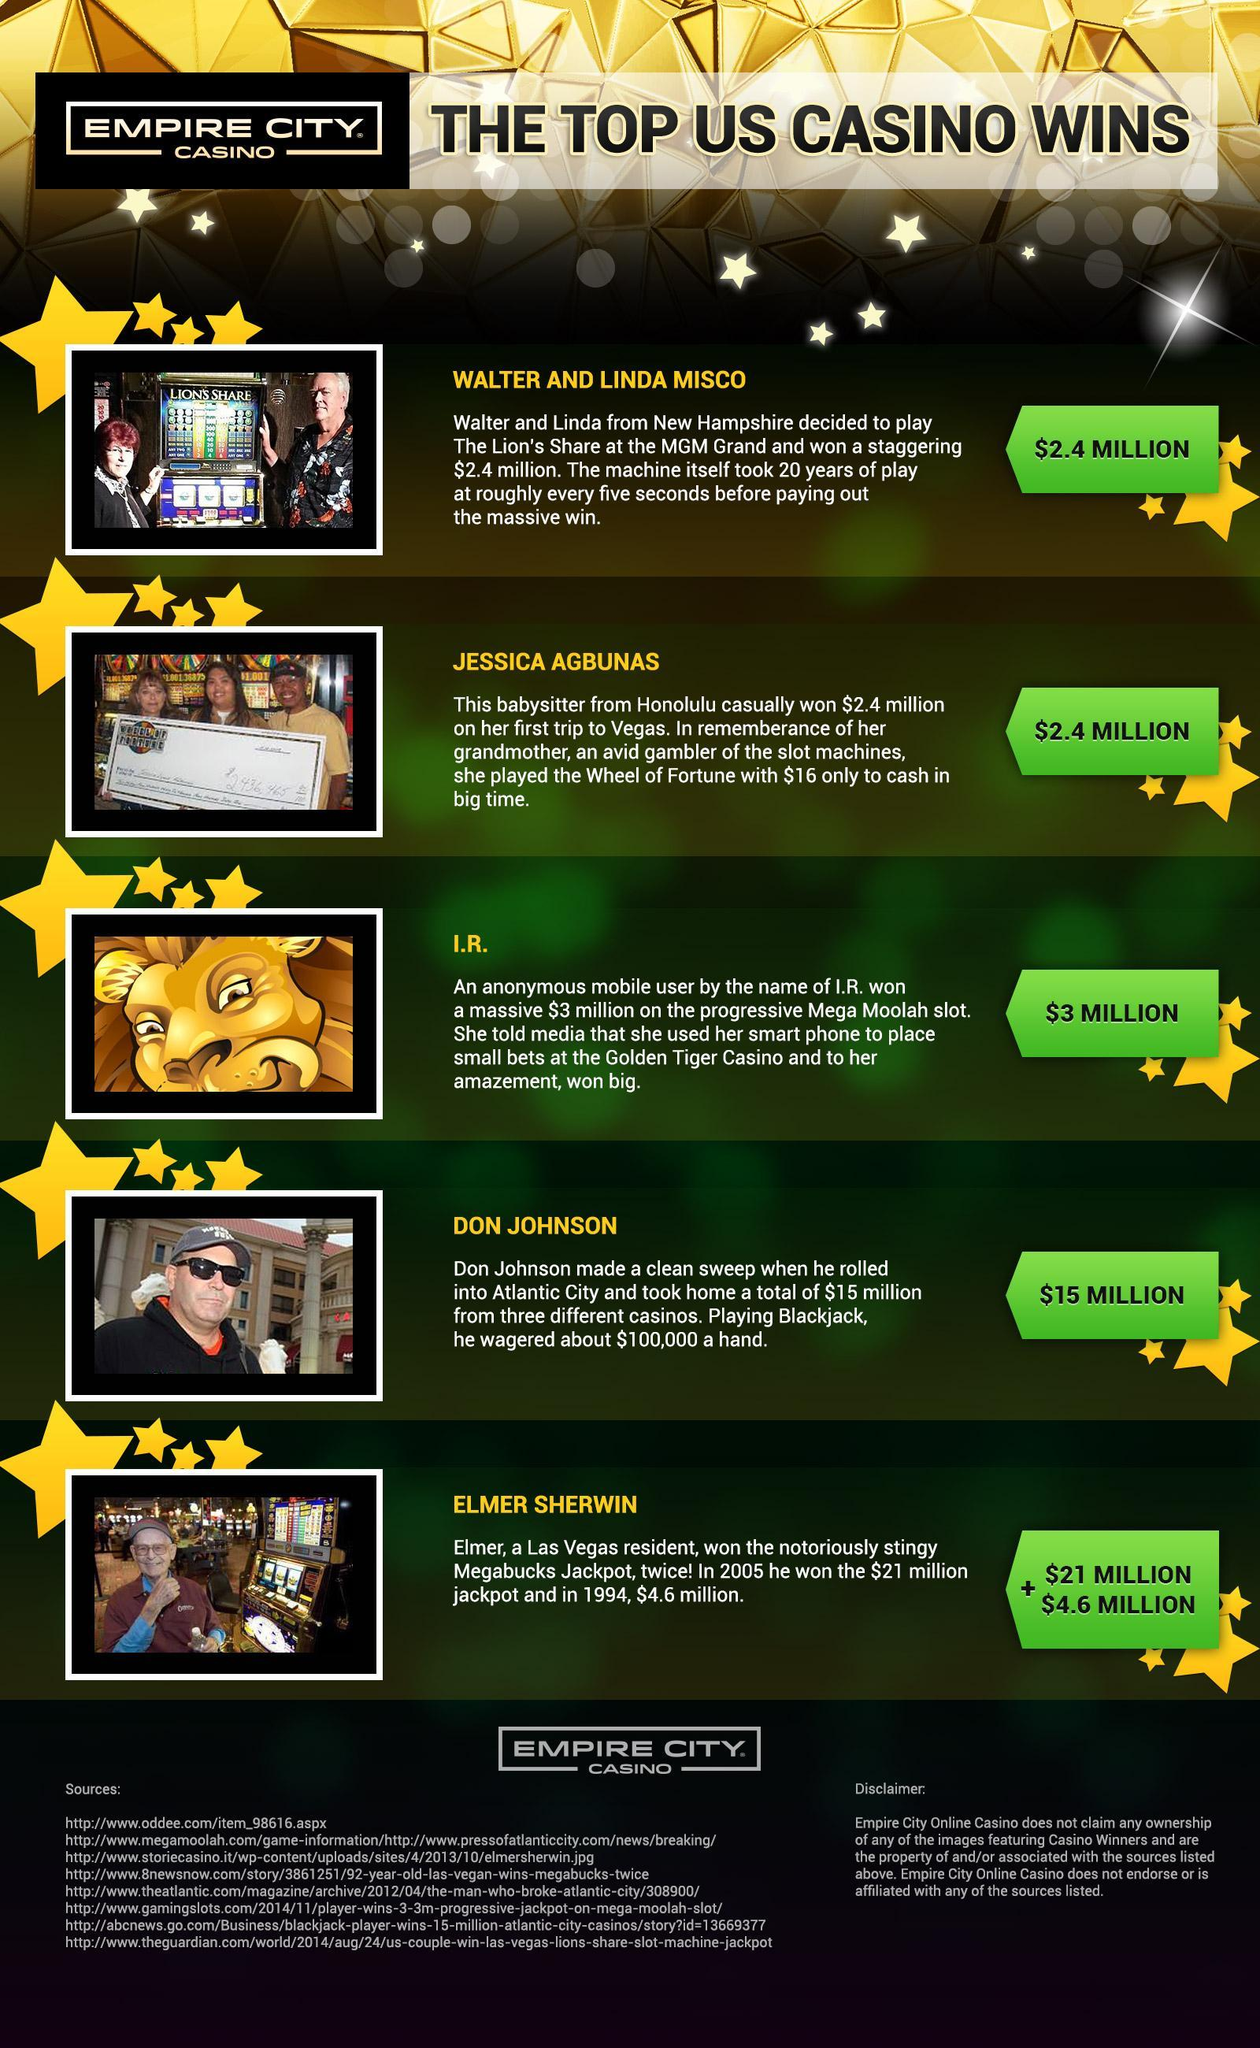Which couple won $2.4 million?
Answer the question with a short phrase. WALTER AND LINDA MISCO What amount did Jessica Agbunas have with her? $16 Who won 25.6 million $ in all from Empire City Casino? ELMER SHERWIN 